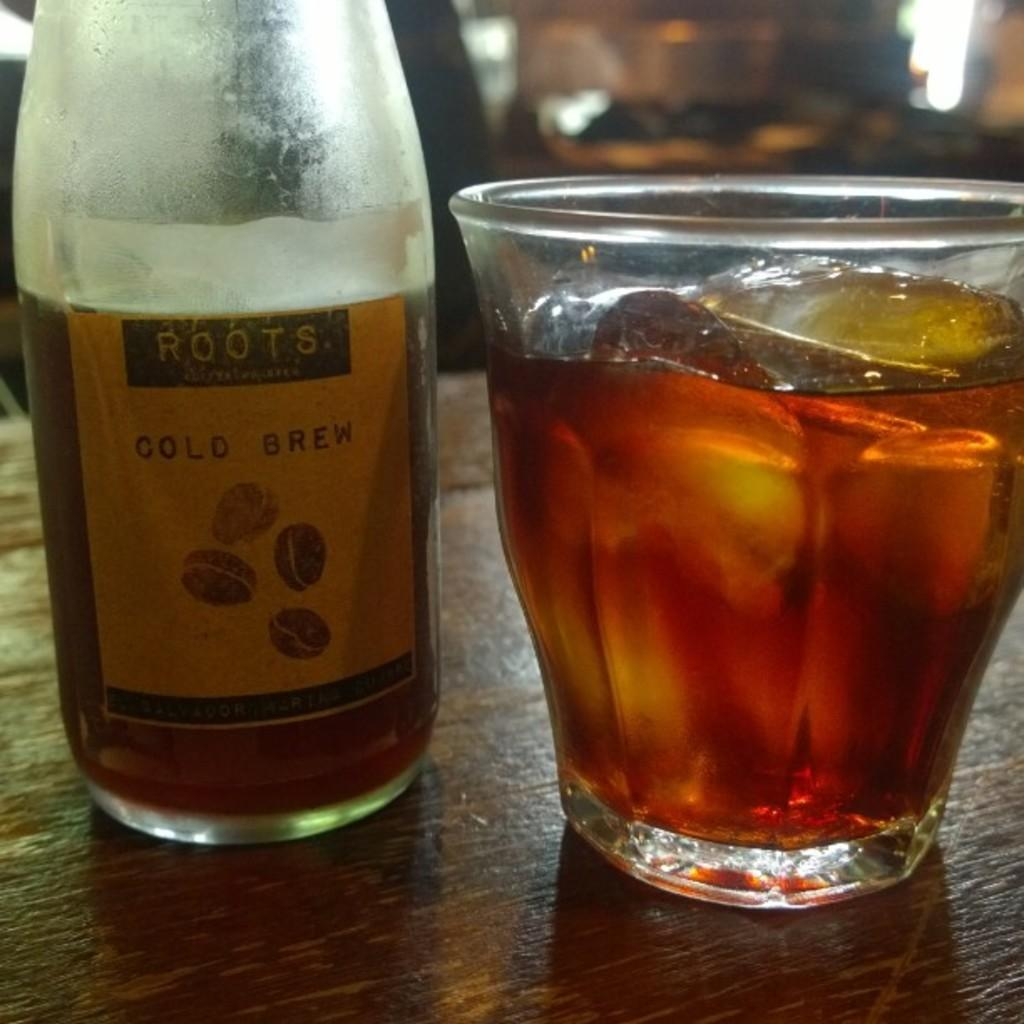What is present in the image that can hold a liquid? There is a bottle and a glass with a drink in the image. What is inside the glass? There are ice cubes in the glass. Where are the bottle, glass, and ice cubes located? The bottle, glass, and ice cubes are on a table. What color of paint is being used to draw a line on the bottle in the image? There is no paint or line present on the bottle in the image. 